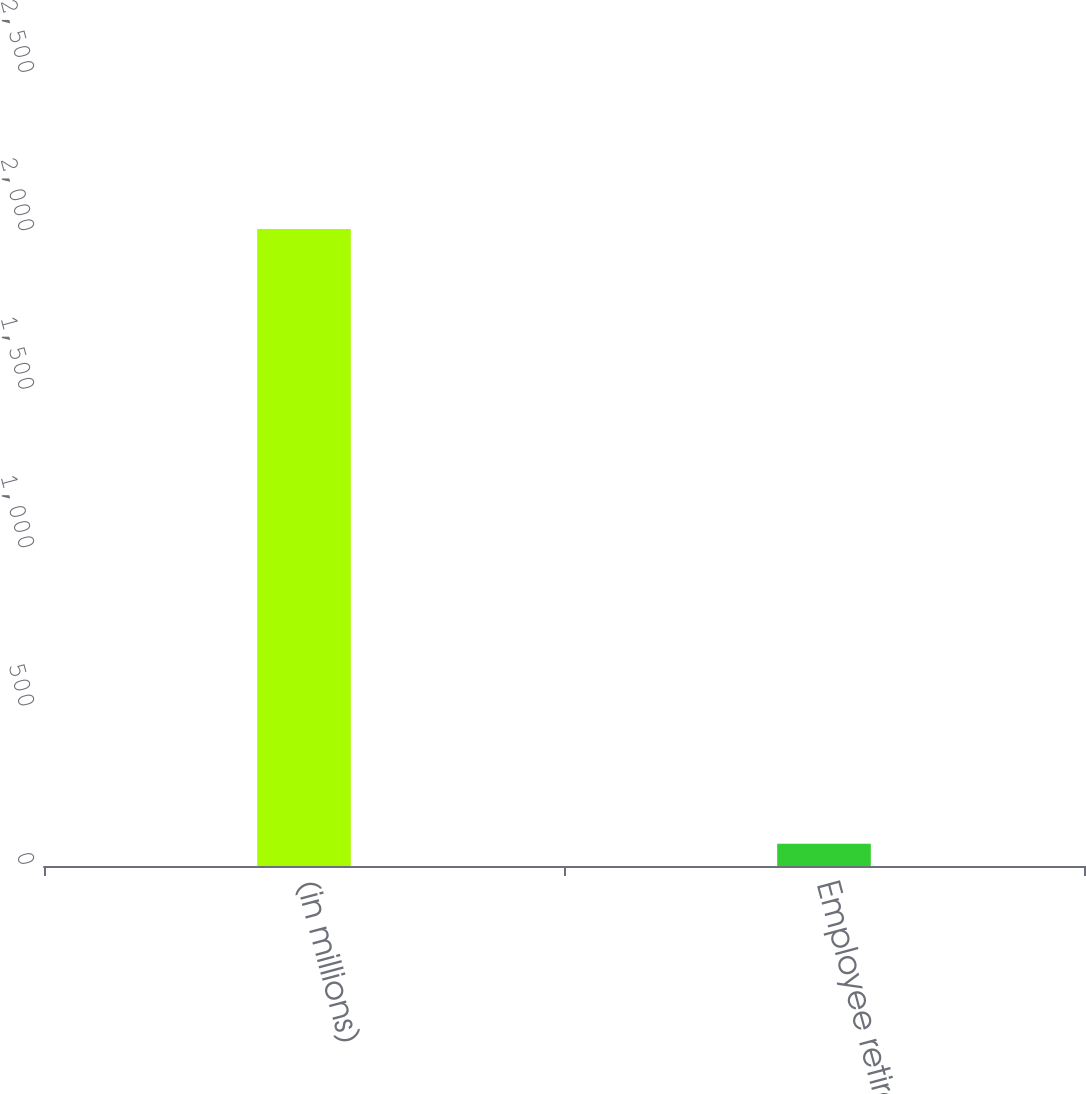Convert chart. <chart><loc_0><loc_0><loc_500><loc_500><bar_chart><fcel>(in millions)<fcel>Employee retirement<nl><fcel>2011<fcel>69.9<nl></chart> 